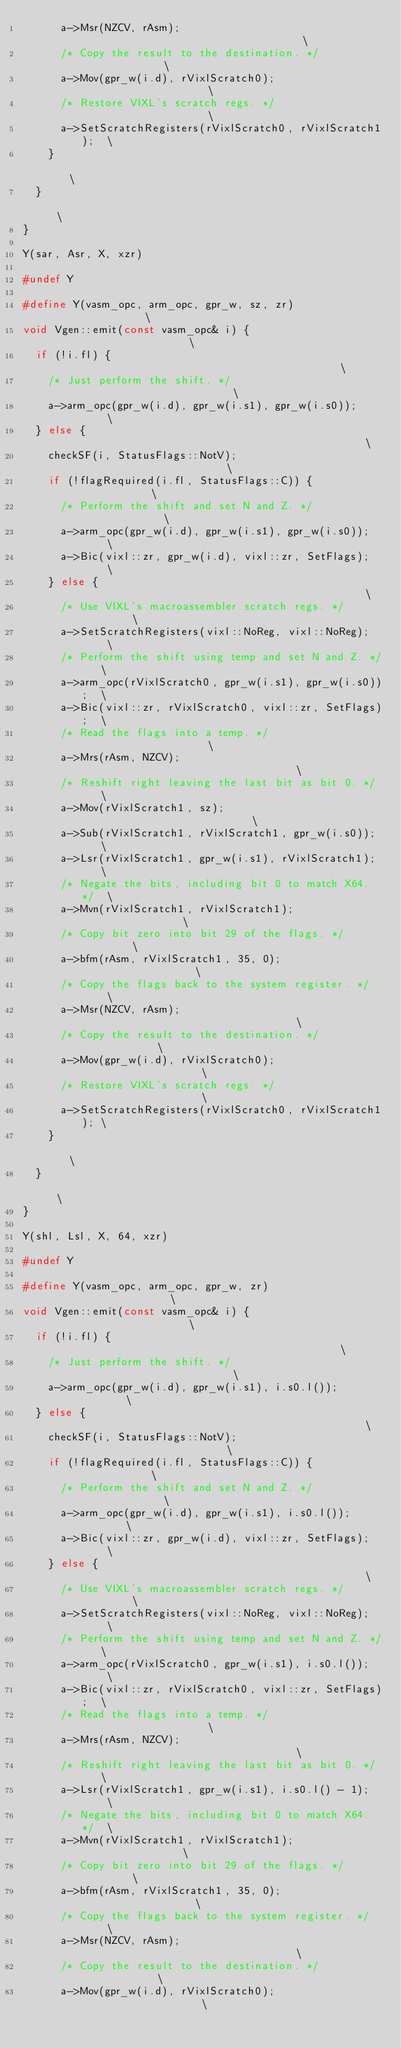Convert code to text. <code><loc_0><loc_0><loc_500><loc_500><_C++_>      a->Msr(NZCV, rAsm);                                    \
      /* Copy the result to the destination. */              \
      a->Mov(gpr_w(i.d), rVixlScratch0);                     \
      /* Restore VIXL's scratch regs. */                     \
      a->SetScratchRegisters(rVixlScratch0, rVixlScratch1);  \
    }                                                        \
  }                                                          \
}

Y(sar, Asr, X, xzr)

#undef Y

#define Y(vasm_opc, arm_opc, gpr_w, sz, zr)                 \
void Vgen::emit(const vasm_opc& i) {                        \
  if (!i.fl) {                                              \
    /* Just perform the shift. */                           \
    a->arm_opc(gpr_w(i.d), gpr_w(i.s1), gpr_w(i.s0));       \
  } else {                                                  \
    checkSF(i, StatusFlags::NotV);                          \
    if (!flagRequired(i.fl, StatusFlags::C)) {              \
      /* Perform the shift and set N and Z. */              \
      a->arm_opc(gpr_w(i.d), gpr_w(i.s1), gpr_w(i.s0));     \
      a->Bic(vixl::zr, gpr_w(i.d), vixl::zr, SetFlags);     \
    } else {                                                \
      /* Use VIXL's macroassembler scratch regs. */         \
      a->SetScratchRegisters(vixl::NoReg, vixl::NoReg);     \
      /* Perform the shift using temp and set N and Z. */   \
      a->arm_opc(rVixlScratch0, gpr_w(i.s1), gpr_w(i.s0));  \
      a->Bic(vixl::zr, rVixlScratch0, vixl::zr, SetFlags);  \
      /* Read the flags into a temp. */                     \
      a->Mrs(rAsm, NZCV);                                   \
      /* Reshift right leaving the last bit as bit 0. */    \
      a->Mov(rVixlScratch1, sz);                            \
      a->Sub(rVixlScratch1, rVixlScratch1, gpr_w(i.s0));    \
      a->Lsr(rVixlScratch1, gpr_w(i.s1), rVixlScratch1);    \
      /* Negate the bits, including bit 0 to match X64. */  \
      a->Mvn(rVixlScratch1, rVixlScratch1);                 \
      /* Copy bit zero into bit 29 of the flags. */         \
      a->bfm(rAsm, rVixlScratch1, 35, 0);                   \
      /* Copy the flags back to the system register. */     \
      a->Msr(NZCV, rAsm);                                   \
      /* Copy the result to the destination. */             \
      a->Mov(gpr_w(i.d), rVixlScratch0);                    \
      /* Restore VIXL's scratch regs. */                    \
      a->SetScratchRegisters(rVixlScratch0, rVixlScratch1); \
    }                                                       \
  }                                                         \
}

Y(shl, Lsl, X, 64, xzr)

#undef Y

#define Y(vasm_opc, arm_opc, gpr_w, zr)                     \
void Vgen::emit(const vasm_opc& i) {                        \
  if (!i.fl) {                                              \
    /* Just perform the shift. */                           \
    a->arm_opc(gpr_w(i.d), gpr_w(i.s1), i.s0.l());          \
  } else {                                                  \
    checkSF(i, StatusFlags::NotV);                          \
    if (!flagRequired(i.fl, StatusFlags::C)) {              \
      /* Perform the shift and set N and Z. */              \
      a->arm_opc(gpr_w(i.d), gpr_w(i.s1), i.s0.l());        \
      a->Bic(vixl::zr, gpr_w(i.d), vixl::zr, SetFlags);     \
    } else {                                                \
      /* Use VIXL's macroassembler scratch regs. */         \
      a->SetScratchRegisters(vixl::NoReg, vixl::NoReg);     \
      /* Perform the shift using temp and set N and Z. */   \
      a->arm_opc(rVixlScratch0, gpr_w(i.s1), i.s0.l());     \
      a->Bic(vixl::zr, rVixlScratch0, vixl::zr, SetFlags);  \
      /* Read the flags into a temp. */                     \
      a->Mrs(rAsm, NZCV);                                   \
      /* Reshift right leaving the last bit as bit 0. */    \
      a->Lsr(rVixlScratch1, gpr_w(i.s1), i.s0.l() - 1);     \
      /* Negate the bits, including bit 0 to match X64. */  \
      a->Mvn(rVixlScratch1, rVixlScratch1);                 \
      /* Copy bit zero into bit 29 of the flags. */         \
      a->bfm(rAsm, rVixlScratch1, 35, 0);                   \
      /* Copy the flags back to the system register. */     \
      a->Msr(NZCV, rAsm);                                   \
      /* Copy the result to the destination. */             \
      a->Mov(gpr_w(i.d), rVixlScratch0);                    \</code> 